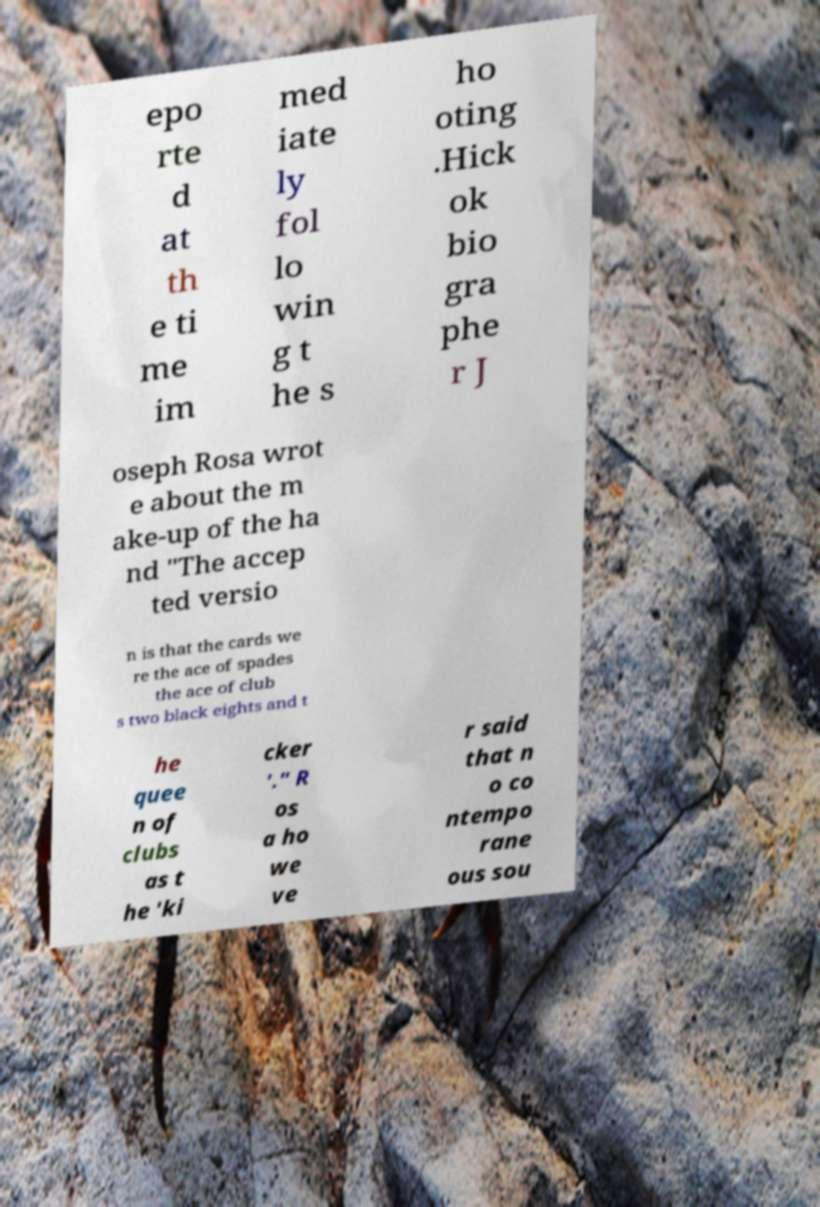Could you assist in decoding the text presented in this image and type it out clearly? epo rte d at th e ti me im med iate ly fol lo win g t he s ho oting .Hick ok bio gra phe r J oseph Rosa wrot e about the m ake-up of the ha nd "The accep ted versio n is that the cards we re the ace of spades the ace of club s two black eights and t he quee n of clubs as t he 'ki cker '." R os a ho we ve r said that n o co ntempo rane ous sou 